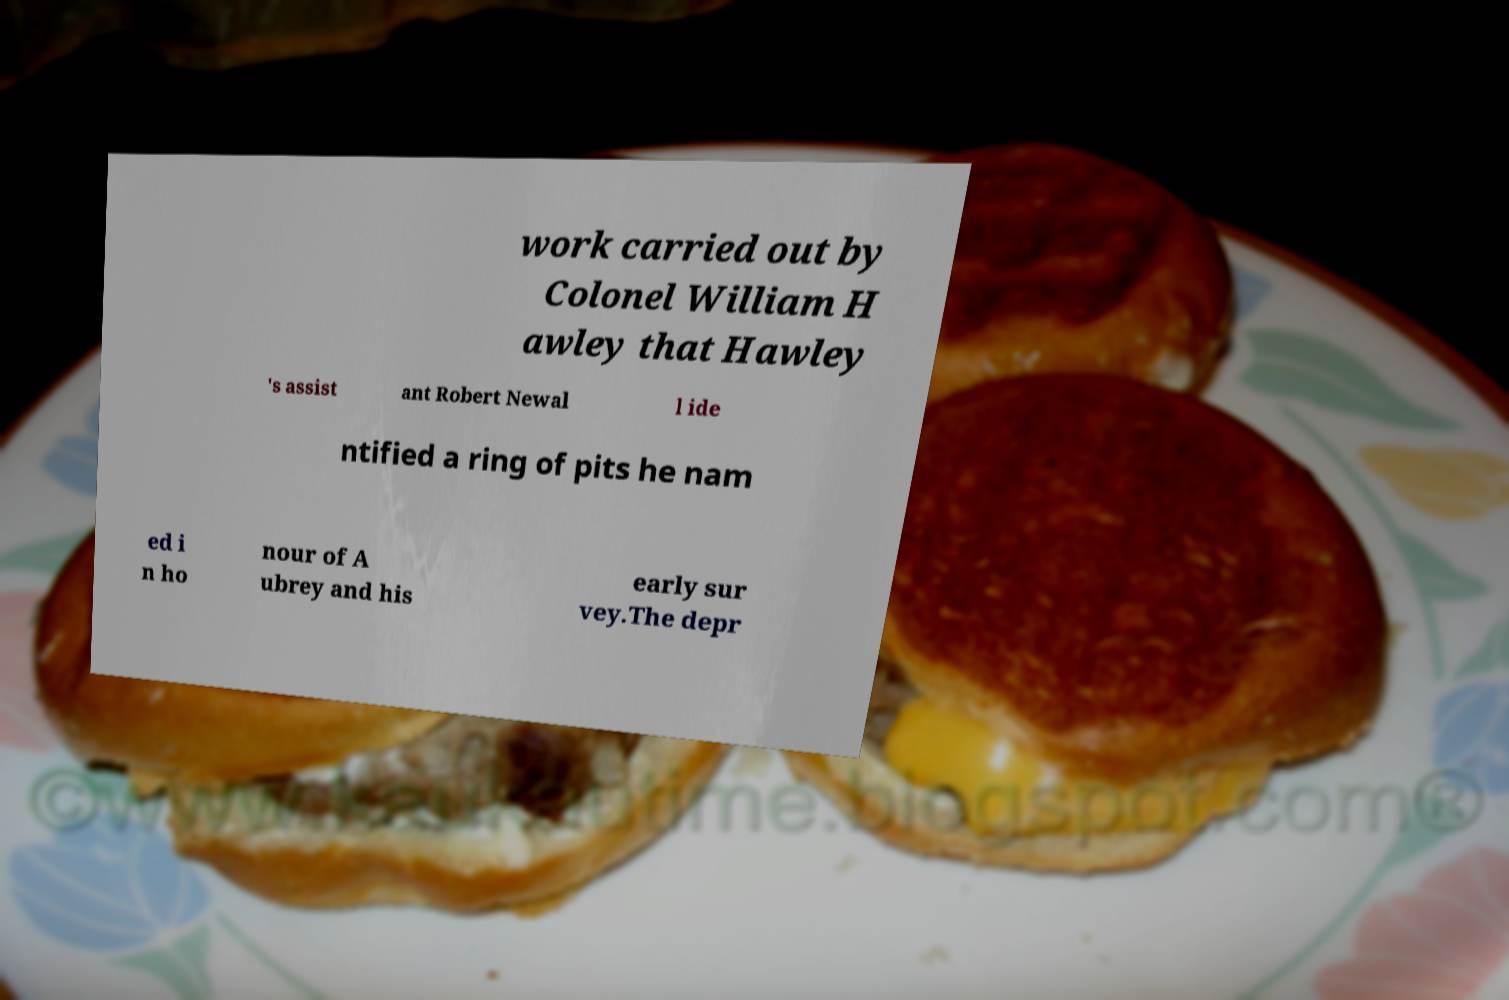Can you read and provide the text displayed in the image?This photo seems to have some interesting text. Can you extract and type it out for me? work carried out by Colonel William H awley that Hawley 's assist ant Robert Newal l ide ntified a ring of pits he nam ed i n ho nour of A ubrey and his early sur vey.The depr 